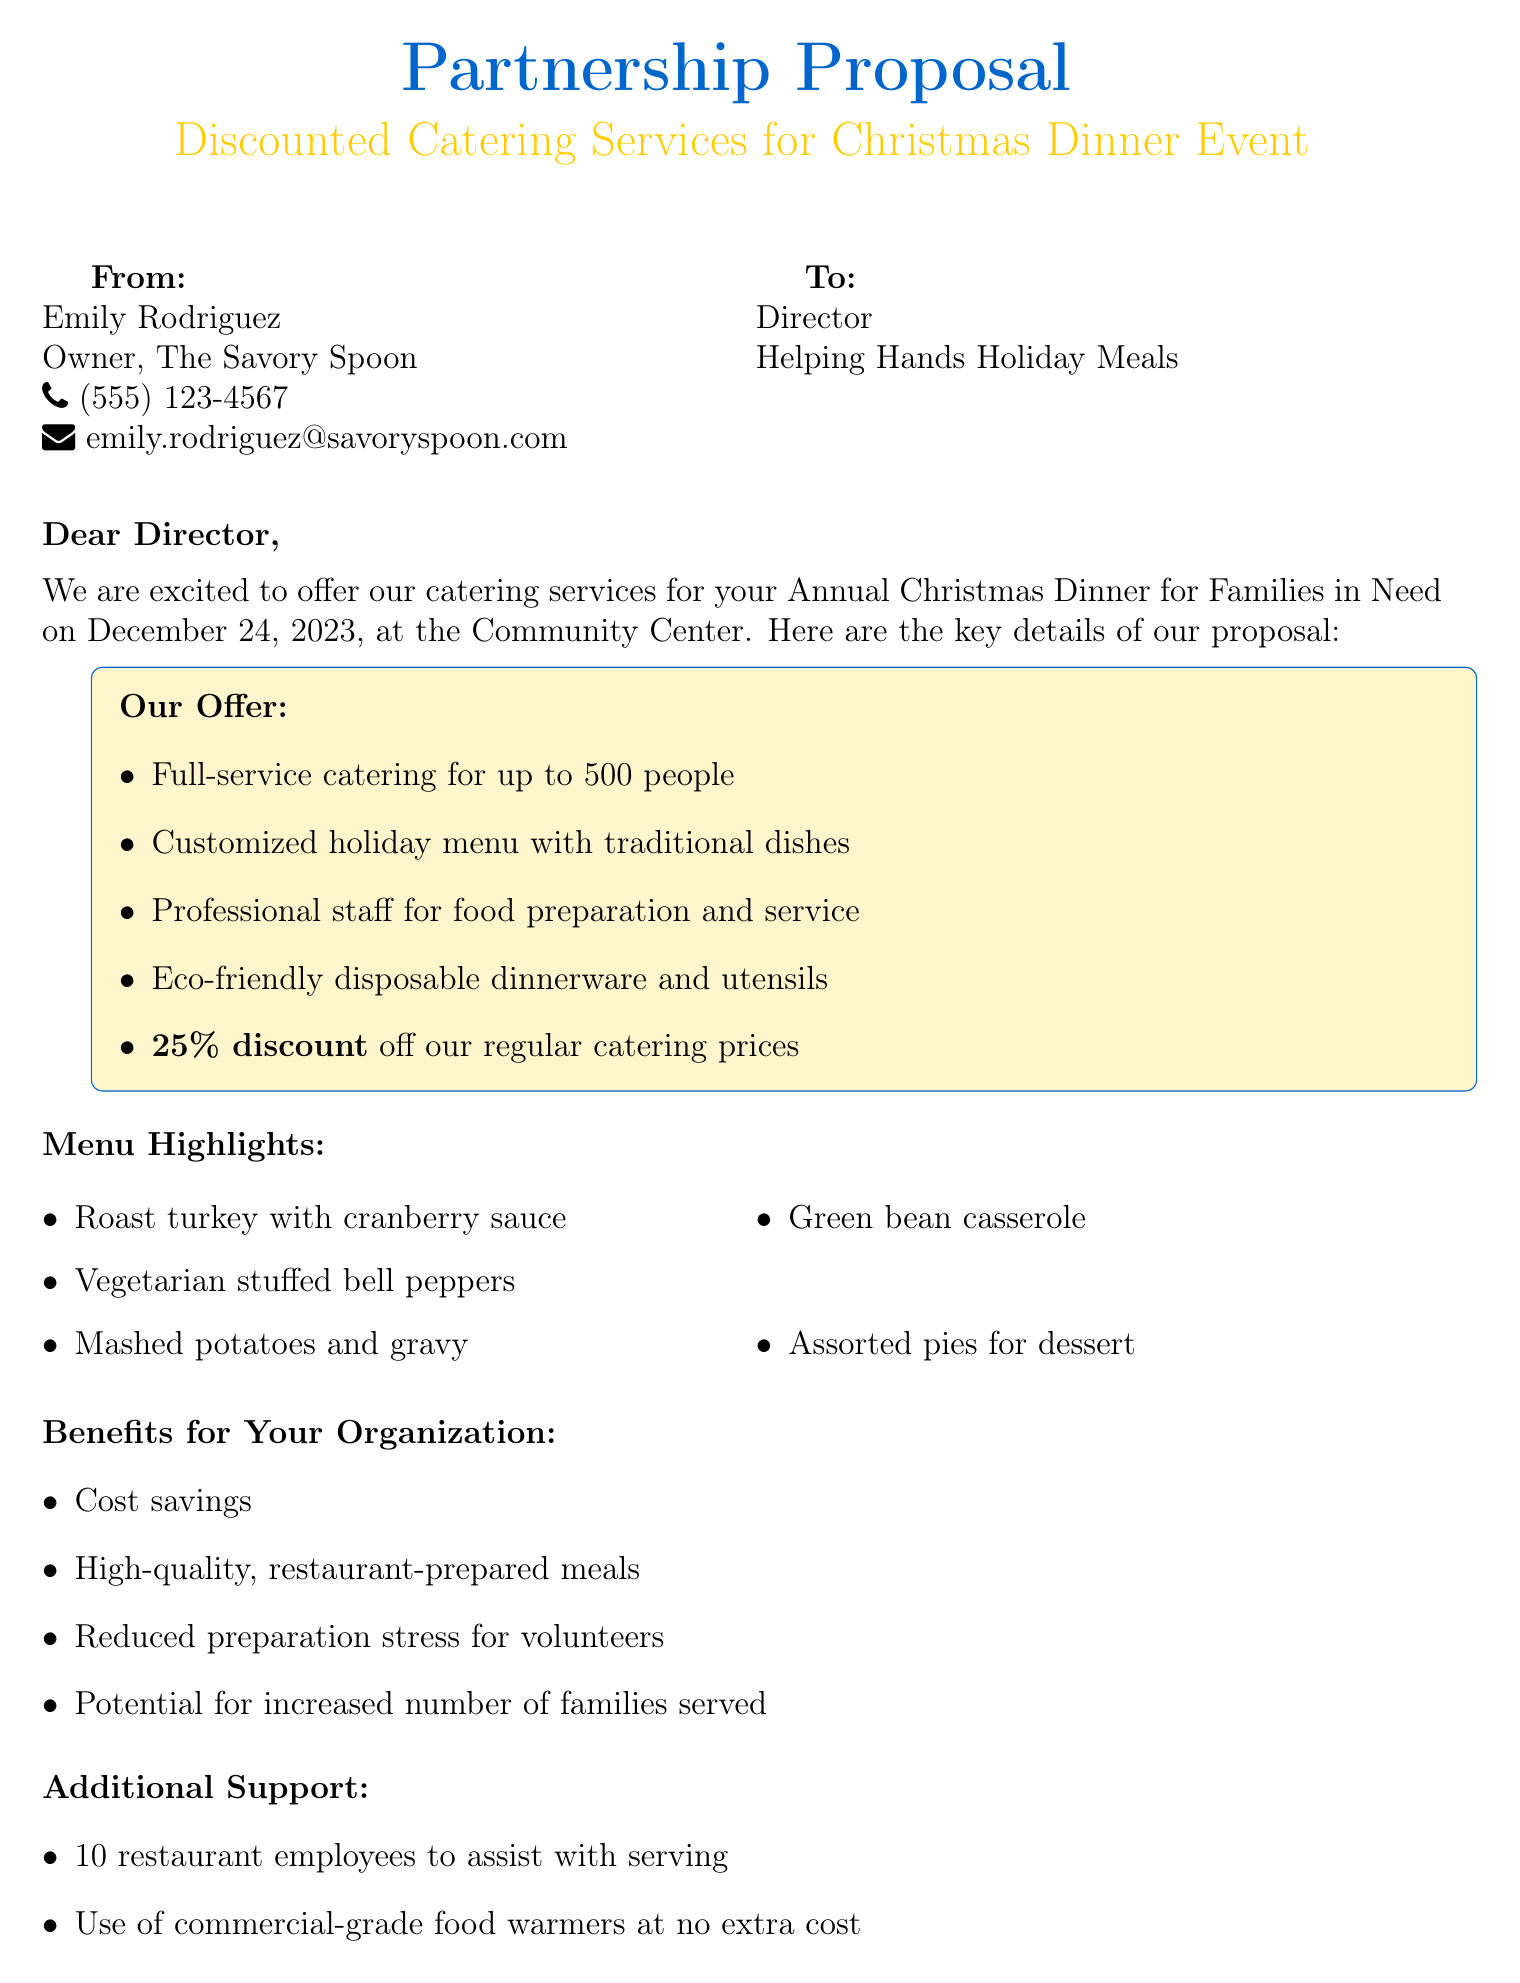What is the date of the Christmas dinner event? The date of the event is explicitly mentioned in the proposal details section.
Answer: December 24, 2023 Who is the sender of the email? The sender's name and position are provided at the beginning of the document.
Answer: Emily Rodriguez What discount is offered on catering services? The discount is clearly stated in the offered services section.
Answer: 25% off How many people can the catering service accommodate? The proposal details mention the capacity of the catering service directly.
Answer: Up to 500 people What are two menu highlights listed in the email? Menu highlights are listed under a specific section and include various dishes.
Answer: Roast turkey, vegetarian stuffed bell peppers What additional support is offered alongside the catering services? The additional support details are provided in a specific section mentioning staff and equipment.
Answer: 10 restaurant employees and commercial-grade food warmers What is the offer related to food waste? The commitment regarding food waste is stated in the social responsibility section.
Answer: Donating excess food to local shelters What is the call to action in the email? The call to action encourages a specific next step, which is mentioned clearly.
Answer: Schedule a tasting and discuss further details at your convenience 